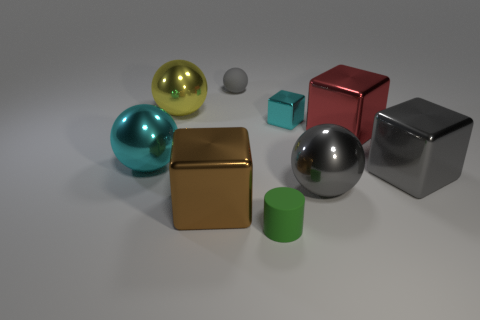Subtract all balls. How many objects are left? 5 Subtract all small green cylinders. Subtract all red rubber cylinders. How many objects are left? 8 Add 9 large gray metal balls. How many large gray metal balls are left? 10 Add 8 gray balls. How many gray balls exist? 10 Subtract 0 green spheres. How many objects are left? 9 